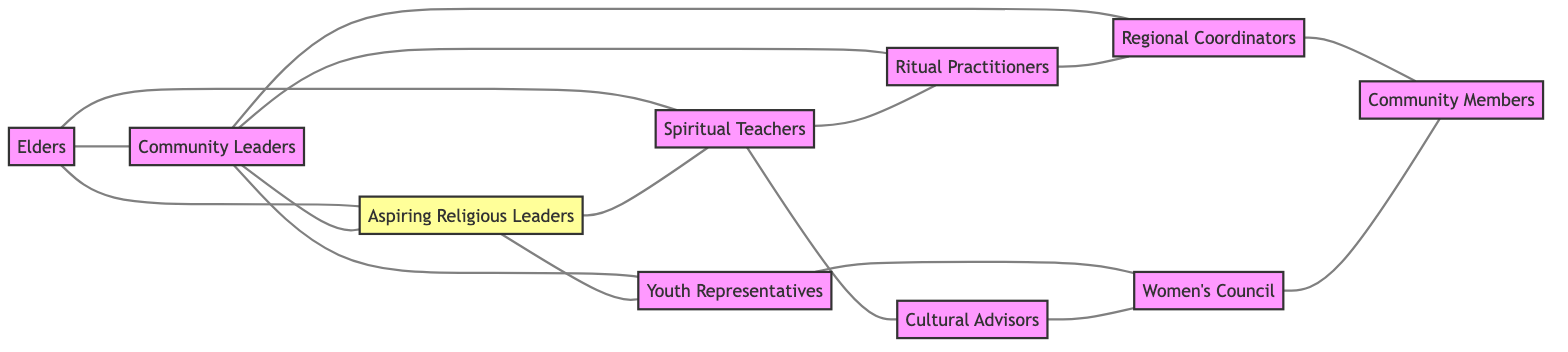What are the total number of nodes in the diagram? The diagram lists the nodes at the beginning, showing a total of ten distinct roles within the religious community.
Answer: 10 Which node is connected to both Elders and Community Leaders? Checking the edges originating from the Elders and Community Leaders, the Aspiring Religious Leaders are directly linked to both nodes.
Answer: Aspiring Religious Leaders How many connections does the Women’s Council have? Analyzing the connections for the Women’s Council, it shows two edges: one to Youth Representatives and one to Community Members.
Answer: 2 What role connects to the maximum number of other nodes? Observing the nodes, Community Leaders connect to four other roles: Aspiring Religious Leaders, Ritual Practitioners, Youth Representatives, and Regional Coordinators. This is the highest connection count seen in the diagram.
Answer: Community Leaders Which roles are directly connected to the Spiritual Teachers? By examining the edges, the Spiritual Teachers connect directly to Aspiring Religious Leaders, Ritual Practitioners, and Cultural Advisors.
Answer: Aspiring Religious Leaders, Ritual Practitioners, Cultural Advisors How many edges are present in the graph? Counting the unique connections illustrated in the edges section reveals a total of fifteen distinct connections between the nodes.
Answer: 15 Is there a connection between Youth Representatives and Community Members? Looking at the edges, there is no direct connection listed between Youth Representatives and Community Members, confirming they are not directly related in this context.
Answer: No Which node connects to the Cultural Advisors? The Cultural Advisors have a direct edge to the Spiritual Teachers, making them the only node connecting with Cultural Advisors in this graph.
Answer: Spiritual Teachers What are the roles that connect both Elders and Regional Coordinators? By reviewing the connections, the Community Leaders connect both Elders and, through an edge, lead to Regional Coordinators, making them the linking role.
Answer: Community Leaders 